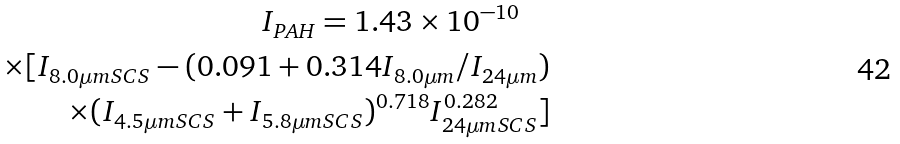Convert formula to latex. <formula><loc_0><loc_0><loc_500><loc_500>I _ { P A H } = 1 . 4 3 \times 1 0 ^ { - 1 0 } \quad \\ \times [ I _ { 8 . 0 \mu m S C S } - ( 0 . 0 9 1 + 0 . 3 1 4 I _ { 8 . 0 \mu m } / I _ { 2 4 \mu m } ) \\ \times ( I _ { 4 . 5 \mu m S C S } + I _ { 5 . 8 \mu m S C S } ) ^ { 0 . 7 1 8 } I _ { 2 4 \mu m S C S } ^ { 0 . 2 8 2 } ]</formula> 